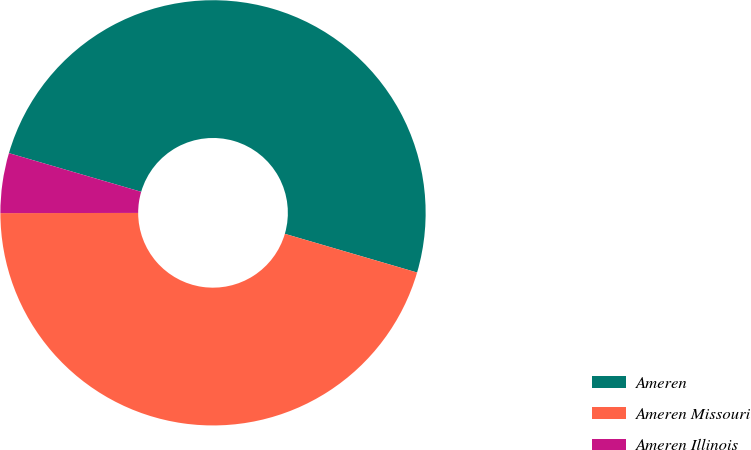Convert chart. <chart><loc_0><loc_0><loc_500><loc_500><pie_chart><fcel>Ameren<fcel>Ameren Missouri<fcel>Ameren Illinois<nl><fcel>50.0%<fcel>45.45%<fcel>4.55%<nl></chart> 